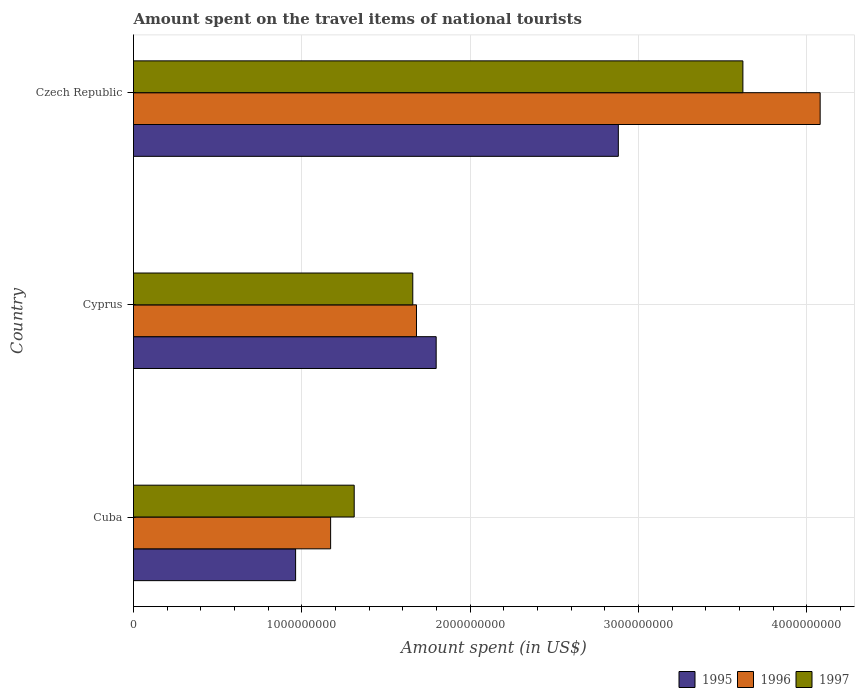How many different coloured bars are there?
Provide a succinct answer. 3. Are the number of bars on each tick of the Y-axis equal?
Offer a terse response. Yes. How many bars are there on the 2nd tick from the bottom?
Ensure brevity in your answer.  3. What is the label of the 1st group of bars from the top?
Provide a short and direct response. Czech Republic. What is the amount spent on the travel items of national tourists in 1995 in Cuba?
Provide a short and direct response. 9.63e+08. Across all countries, what is the maximum amount spent on the travel items of national tourists in 1996?
Your answer should be very brief. 4.08e+09. Across all countries, what is the minimum amount spent on the travel items of national tourists in 1995?
Your answer should be very brief. 9.63e+08. In which country was the amount spent on the travel items of national tourists in 1996 maximum?
Keep it short and to the point. Czech Republic. In which country was the amount spent on the travel items of national tourists in 1997 minimum?
Your response must be concise. Cuba. What is the total amount spent on the travel items of national tourists in 1997 in the graph?
Your response must be concise. 6.59e+09. What is the difference between the amount spent on the travel items of national tourists in 1995 in Cyprus and that in Czech Republic?
Make the answer very short. -1.08e+09. What is the difference between the amount spent on the travel items of national tourists in 1996 in Czech Republic and the amount spent on the travel items of national tourists in 1995 in Cyprus?
Your answer should be compact. 2.28e+09. What is the average amount spent on the travel items of national tourists in 1997 per country?
Provide a succinct answer. 2.20e+09. What is the difference between the amount spent on the travel items of national tourists in 1995 and amount spent on the travel items of national tourists in 1996 in Cuba?
Ensure brevity in your answer.  -2.08e+08. In how many countries, is the amount spent on the travel items of national tourists in 1995 greater than 2000000000 US$?
Your response must be concise. 1. What is the ratio of the amount spent on the travel items of national tourists in 1997 in Cuba to that in Czech Republic?
Ensure brevity in your answer.  0.36. Is the difference between the amount spent on the travel items of national tourists in 1995 in Cuba and Czech Republic greater than the difference between the amount spent on the travel items of national tourists in 1996 in Cuba and Czech Republic?
Your answer should be compact. Yes. What is the difference between the highest and the second highest amount spent on the travel items of national tourists in 1996?
Your answer should be very brief. 2.40e+09. What is the difference between the highest and the lowest amount spent on the travel items of national tourists in 1996?
Give a very brief answer. 2.91e+09. In how many countries, is the amount spent on the travel items of national tourists in 1996 greater than the average amount spent on the travel items of national tourists in 1996 taken over all countries?
Keep it short and to the point. 1. Is the sum of the amount spent on the travel items of national tourists in 1996 in Cuba and Cyprus greater than the maximum amount spent on the travel items of national tourists in 1995 across all countries?
Give a very brief answer. No. What does the 1st bar from the top in Czech Republic represents?
Your answer should be compact. 1997. Is it the case that in every country, the sum of the amount spent on the travel items of national tourists in 1997 and amount spent on the travel items of national tourists in 1996 is greater than the amount spent on the travel items of national tourists in 1995?
Give a very brief answer. Yes. How many bars are there?
Make the answer very short. 9. Does the graph contain any zero values?
Offer a very short reply. No. How are the legend labels stacked?
Your response must be concise. Horizontal. What is the title of the graph?
Keep it short and to the point. Amount spent on the travel items of national tourists. What is the label or title of the X-axis?
Keep it short and to the point. Amount spent (in US$). What is the Amount spent (in US$) in 1995 in Cuba?
Your answer should be very brief. 9.63e+08. What is the Amount spent (in US$) of 1996 in Cuba?
Give a very brief answer. 1.17e+09. What is the Amount spent (in US$) in 1997 in Cuba?
Your answer should be very brief. 1.31e+09. What is the Amount spent (in US$) in 1995 in Cyprus?
Offer a very short reply. 1.80e+09. What is the Amount spent (in US$) of 1996 in Cyprus?
Ensure brevity in your answer.  1.68e+09. What is the Amount spent (in US$) in 1997 in Cyprus?
Your response must be concise. 1.66e+09. What is the Amount spent (in US$) of 1995 in Czech Republic?
Provide a succinct answer. 2.88e+09. What is the Amount spent (in US$) in 1996 in Czech Republic?
Offer a very short reply. 4.08e+09. What is the Amount spent (in US$) in 1997 in Czech Republic?
Ensure brevity in your answer.  3.62e+09. Across all countries, what is the maximum Amount spent (in US$) of 1995?
Provide a succinct answer. 2.88e+09. Across all countries, what is the maximum Amount spent (in US$) in 1996?
Your answer should be very brief. 4.08e+09. Across all countries, what is the maximum Amount spent (in US$) of 1997?
Give a very brief answer. 3.62e+09. Across all countries, what is the minimum Amount spent (in US$) in 1995?
Offer a terse response. 9.63e+08. Across all countries, what is the minimum Amount spent (in US$) in 1996?
Offer a terse response. 1.17e+09. Across all countries, what is the minimum Amount spent (in US$) in 1997?
Offer a terse response. 1.31e+09. What is the total Amount spent (in US$) of 1995 in the graph?
Make the answer very short. 5.64e+09. What is the total Amount spent (in US$) in 1996 in the graph?
Offer a terse response. 6.93e+09. What is the total Amount spent (in US$) in 1997 in the graph?
Provide a short and direct response. 6.59e+09. What is the difference between the Amount spent (in US$) in 1995 in Cuba and that in Cyprus?
Your answer should be very brief. -8.35e+08. What is the difference between the Amount spent (in US$) of 1996 in Cuba and that in Cyprus?
Keep it short and to the point. -5.10e+08. What is the difference between the Amount spent (in US$) in 1997 in Cuba and that in Cyprus?
Provide a succinct answer. -3.48e+08. What is the difference between the Amount spent (in US$) in 1995 in Cuba and that in Czech Republic?
Keep it short and to the point. -1.92e+09. What is the difference between the Amount spent (in US$) of 1996 in Cuba and that in Czech Republic?
Give a very brief answer. -2.91e+09. What is the difference between the Amount spent (in US$) of 1997 in Cuba and that in Czech Republic?
Give a very brief answer. -2.31e+09. What is the difference between the Amount spent (in US$) of 1995 in Cyprus and that in Czech Republic?
Make the answer very short. -1.08e+09. What is the difference between the Amount spent (in US$) in 1996 in Cyprus and that in Czech Republic?
Offer a terse response. -2.40e+09. What is the difference between the Amount spent (in US$) of 1997 in Cyprus and that in Czech Republic?
Offer a very short reply. -1.96e+09. What is the difference between the Amount spent (in US$) in 1995 in Cuba and the Amount spent (in US$) in 1996 in Cyprus?
Ensure brevity in your answer.  -7.18e+08. What is the difference between the Amount spent (in US$) of 1995 in Cuba and the Amount spent (in US$) of 1997 in Cyprus?
Ensure brevity in your answer.  -6.96e+08. What is the difference between the Amount spent (in US$) in 1996 in Cuba and the Amount spent (in US$) in 1997 in Cyprus?
Keep it short and to the point. -4.88e+08. What is the difference between the Amount spent (in US$) in 1995 in Cuba and the Amount spent (in US$) in 1996 in Czech Republic?
Your answer should be very brief. -3.12e+09. What is the difference between the Amount spent (in US$) of 1995 in Cuba and the Amount spent (in US$) of 1997 in Czech Republic?
Ensure brevity in your answer.  -2.66e+09. What is the difference between the Amount spent (in US$) in 1996 in Cuba and the Amount spent (in US$) in 1997 in Czech Republic?
Your answer should be compact. -2.45e+09. What is the difference between the Amount spent (in US$) of 1995 in Cyprus and the Amount spent (in US$) of 1996 in Czech Republic?
Offer a terse response. -2.28e+09. What is the difference between the Amount spent (in US$) in 1995 in Cyprus and the Amount spent (in US$) in 1997 in Czech Republic?
Offer a very short reply. -1.82e+09. What is the difference between the Amount spent (in US$) in 1996 in Cyprus and the Amount spent (in US$) in 1997 in Czech Republic?
Keep it short and to the point. -1.94e+09. What is the average Amount spent (in US$) in 1995 per country?
Provide a succinct answer. 1.88e+09. What is the average Amount spent (in US$) in 1996 per country?
Offer a terse response. 2.31e+09. What is the average Amount spent (in US$) in 1997 per country?
Ensure brevity in your answer.  2.20e+09. What is the difference between the Amount spent (in US$) in 1995 and Amount spent (in US$) in 1996 in Cuba?
Your answer should be very brief. -2.08e+08. What is the difference between the Amount spent (in US$) of 1995 and Amount spent (in US$) of 1997 in Cuba?
Your answer should be compact. -3.48e+08. What is the difference between the Amount spent (in US$) in 1996 and Amount spent (in US$) in 1997 in Cuba?
Offer a terse response. -1.40e+08. What is the difference between the Amount spent (in US$) of 1995 and Amount spent (in US$) of 1996 in Cyprus?
Make the answer very short. 1.17e+08. What is the difference between the Amount spent (in US$) of 1995 and Amount spent (in US$) of 1997 in Cyprus?
Offer a very short reply. 1.39e+08. What is the difference between the Amount spent (in US$) in 1996 and Amount spent (in US$) in 1997 in Cyprus?
Give a very brief answer. 2.20e+07. What is the difference between the Amount spent (in US$) of 1995 and Amount spent (in US$) of 1996 in Czech Republic?
Provide a succinct answer. -1.20e+09. What is the difference between the Amount spent (in US$) in 1995 and Amount spent (in US$) in 1997 in Czech Republic?
Make the answer very short. -7.40e+08. What is the difference between the Amount spent (in US$) of 1996 and Amount spent (in US$) of 1997 in Czech Republic?
Provide a succinct answer. 4.59e+08. What is the ratio of the Amount spent (in US$) of 1995 in Cuba to that in Cyprus?
Your answer should be very brief. 0.54. What is the ratio of the Amount spent (in US$) in 1996 in Cuba to that in Cyprus?
Make the answer very short. 0.7. What is the ratio of the Amount spent (in US$) in 1997 in Cuba to that in Cyprus?
Provide a succinct answer. 0.79. What is the ratio of the Amount spent (in US$) of 1995 in Cuba to that in Czech Republic?
Offer a very short reply. 0.33. What is the ratio of the Amount spent (in US$) of 1996 in Cuba to that in Czech Republic?
Your answer should be very brief. 0.29. What is the ratio of the Amount spent (in US$) in 1997 in Cuba to that in Czech Republic?
Give a very brief answer. 0.36. What is the ratio of the Amount spent (in US$) in 1995 in Cyprus to that in Czech Republic?
Your answer should be very brief. 0.62. What is the ratio of the Amount spent (in US$) of 1996 in Cyprus to that in Czech Republic?
Make the answer very short. 0.41. What is the ratio of the Amount spent (in US$) of 1997 in Cyprus to that in Czech Republic?
Provide a succinct answer. 0.46. What is the difference between the highest and the second highest Amount spent (in US$) of 1995?
Keep it short and to the point. 1.08e+09. What is the difference between the highest and the second highest Amount spent (in US$) of 1996?
Offer a terse response. 2.40e+09. What is the difference between the highest and the second highest Amount spent (in US$) in 1997?
Offer a very short reply. 1.96e+09. What is the difference between the highest and the lowest Amount spent (in US$) in 1995?
Your answer should be compact. 1.92e+09. What is the difference between the highest and the lowest Amount spent (in US$) of 1996?
Offer a very short reply. 2.91e+09. What is the difference between the highest and the lowest Amount spent (in US$) in 1997?
Your answer should be compact. 2.31e+09. 